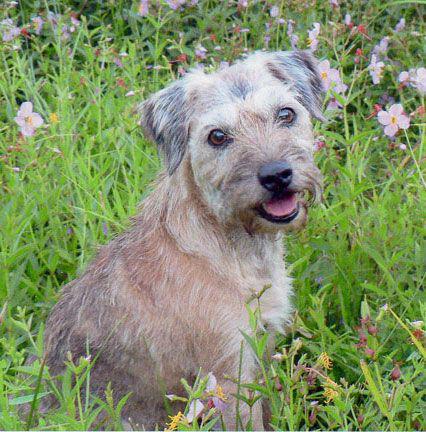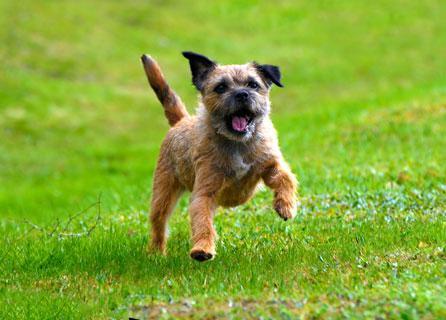The first image is the image on the left, the second image is the image on the right. Given the left and right images, does the statement "At least two dogs are standing." hold true? Answer yes or no. No. The first image is the image on the left, the second image is the image on the right. For the images displayed, is the sentence "The left and right image contains the same number of dogs with at least one sitting in grass." factually correct? Answer yes or no. Yes. 